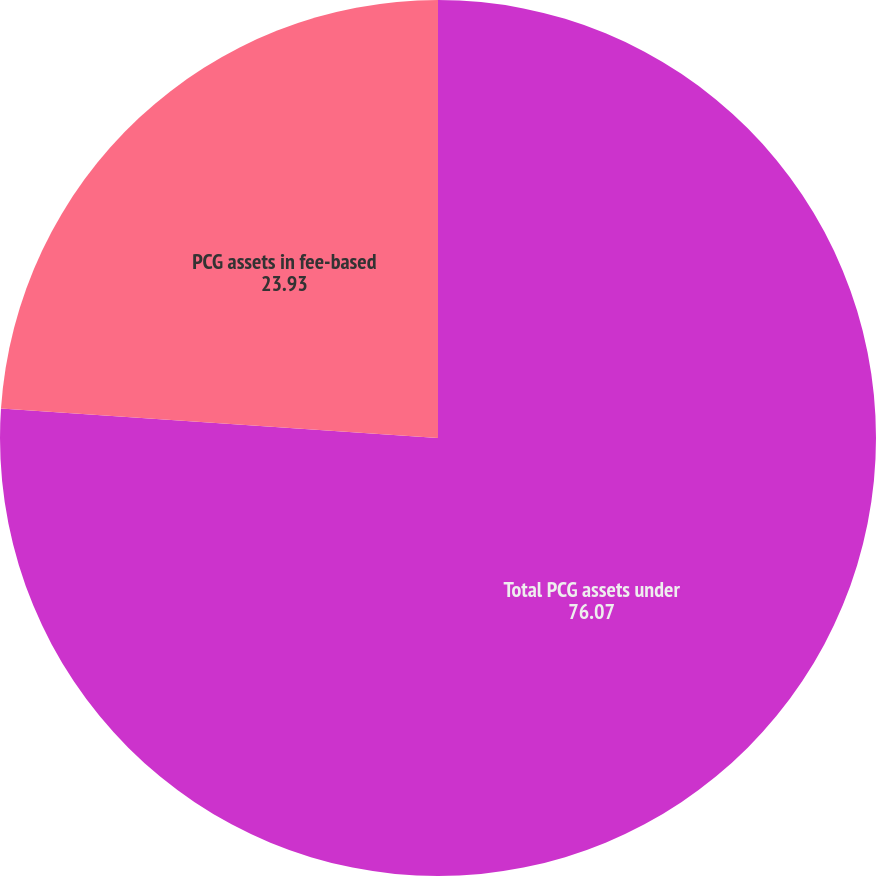Convert chart. <chart><loc_0><loc_0><loc_500><loc_500><pie_chart><fcel>Total PCG assets under<fcel>PCG assets in fee-based<nl><fcel>76.07%<fcel>23.93%<nl></chart> 